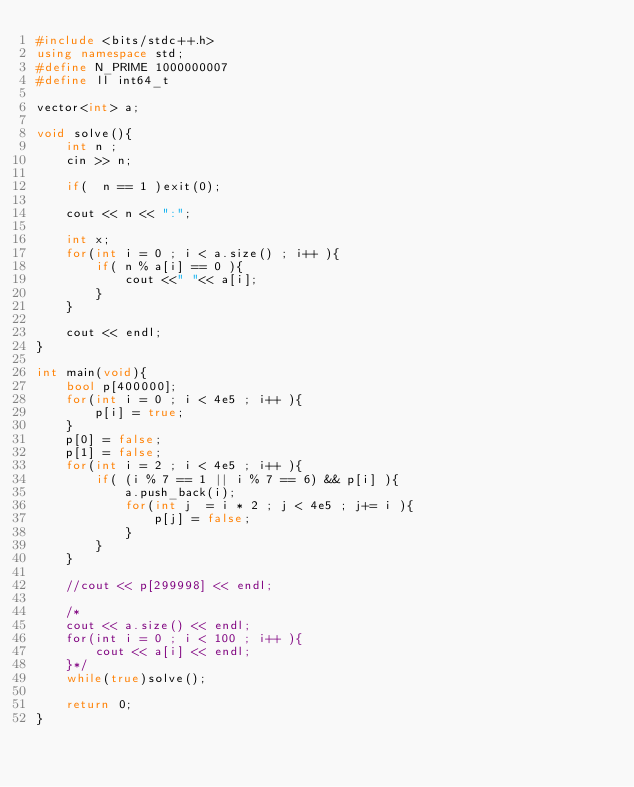Convert code to text. <code><loc_0><loc_0><loc_500><loc_500><_C++_>#include <bits/stdc++.h>
using namespace std;
#define N_PRIME 1000000007
#define ll int64_t

vector<int> a;

void solve(){
    int n ;
    cin >> n;
    
    if(  n == 1 )exit(0);
    
    cout << n << ":";
    
    int x;
    for(int i = 0 ; i < a.size() ; i++ ){
        if( n % a[i] == 0 ){
            cout <<" "<< a[i];
        }
    }
    
    cout << endl;
}

int main(void){
    bool p[400000];
    for(int i = 0 ; i < 4e5 ; i++ ){
        p[i] = true;
    }
    p[0] = false;
    p[1] = false;
    for(int i = 2 ; i < 4e5 ; i++ ){
        if( (i % 7 == 1 || i % 7 == 6) && p[i] ){
            a.push_back(i);
            for(int j  = i * 2 ; j < 4e5 ; j+= i ){
                p[j] = false;
            }
        }
    }
    
    //cout << p[299998] << endl;
    
    /*
    cout << a.size() << endl;
    for(int i = 0 ; i < 100 ; i++ ){
        cout << a[i] << endl;
    }*/
    while(true)solve();
    
    return 0;
}</code> 